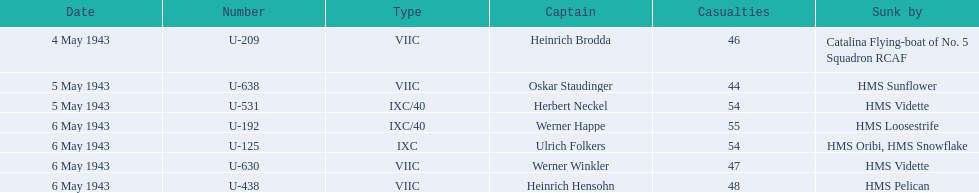Which u-boat was the first to sink U-209. 